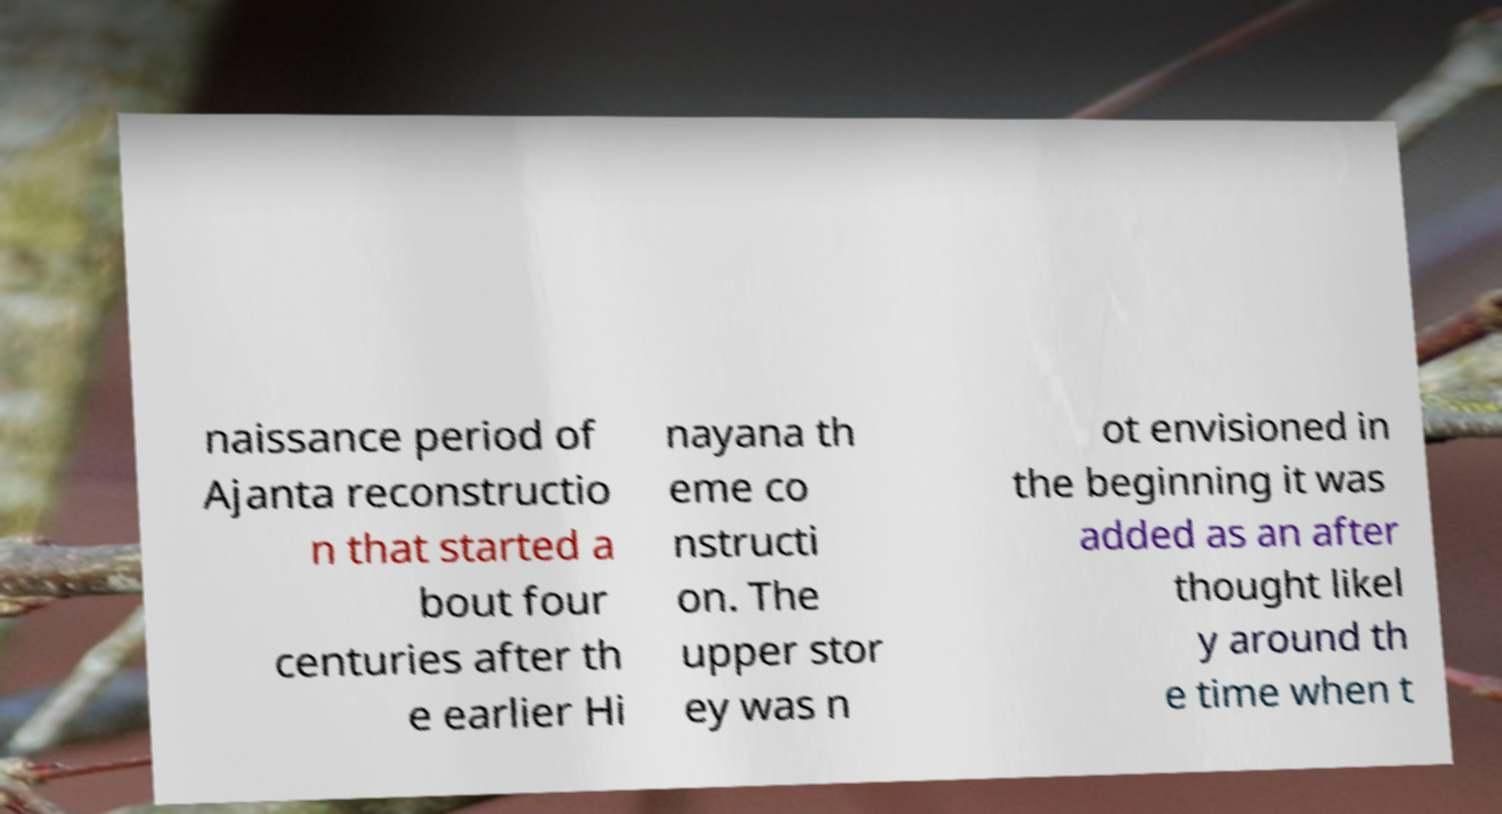There's text embedded in this image that I need extracted. Can you transcribe it verbatim? naissance period of Ajanta reconstructio n that started a bout four centuries after th e earlier Hi nayana th eme co nstructi on. The upper stor ey was n ot envisioned in the beginning it was added as an after thought likel y around th e time when t 